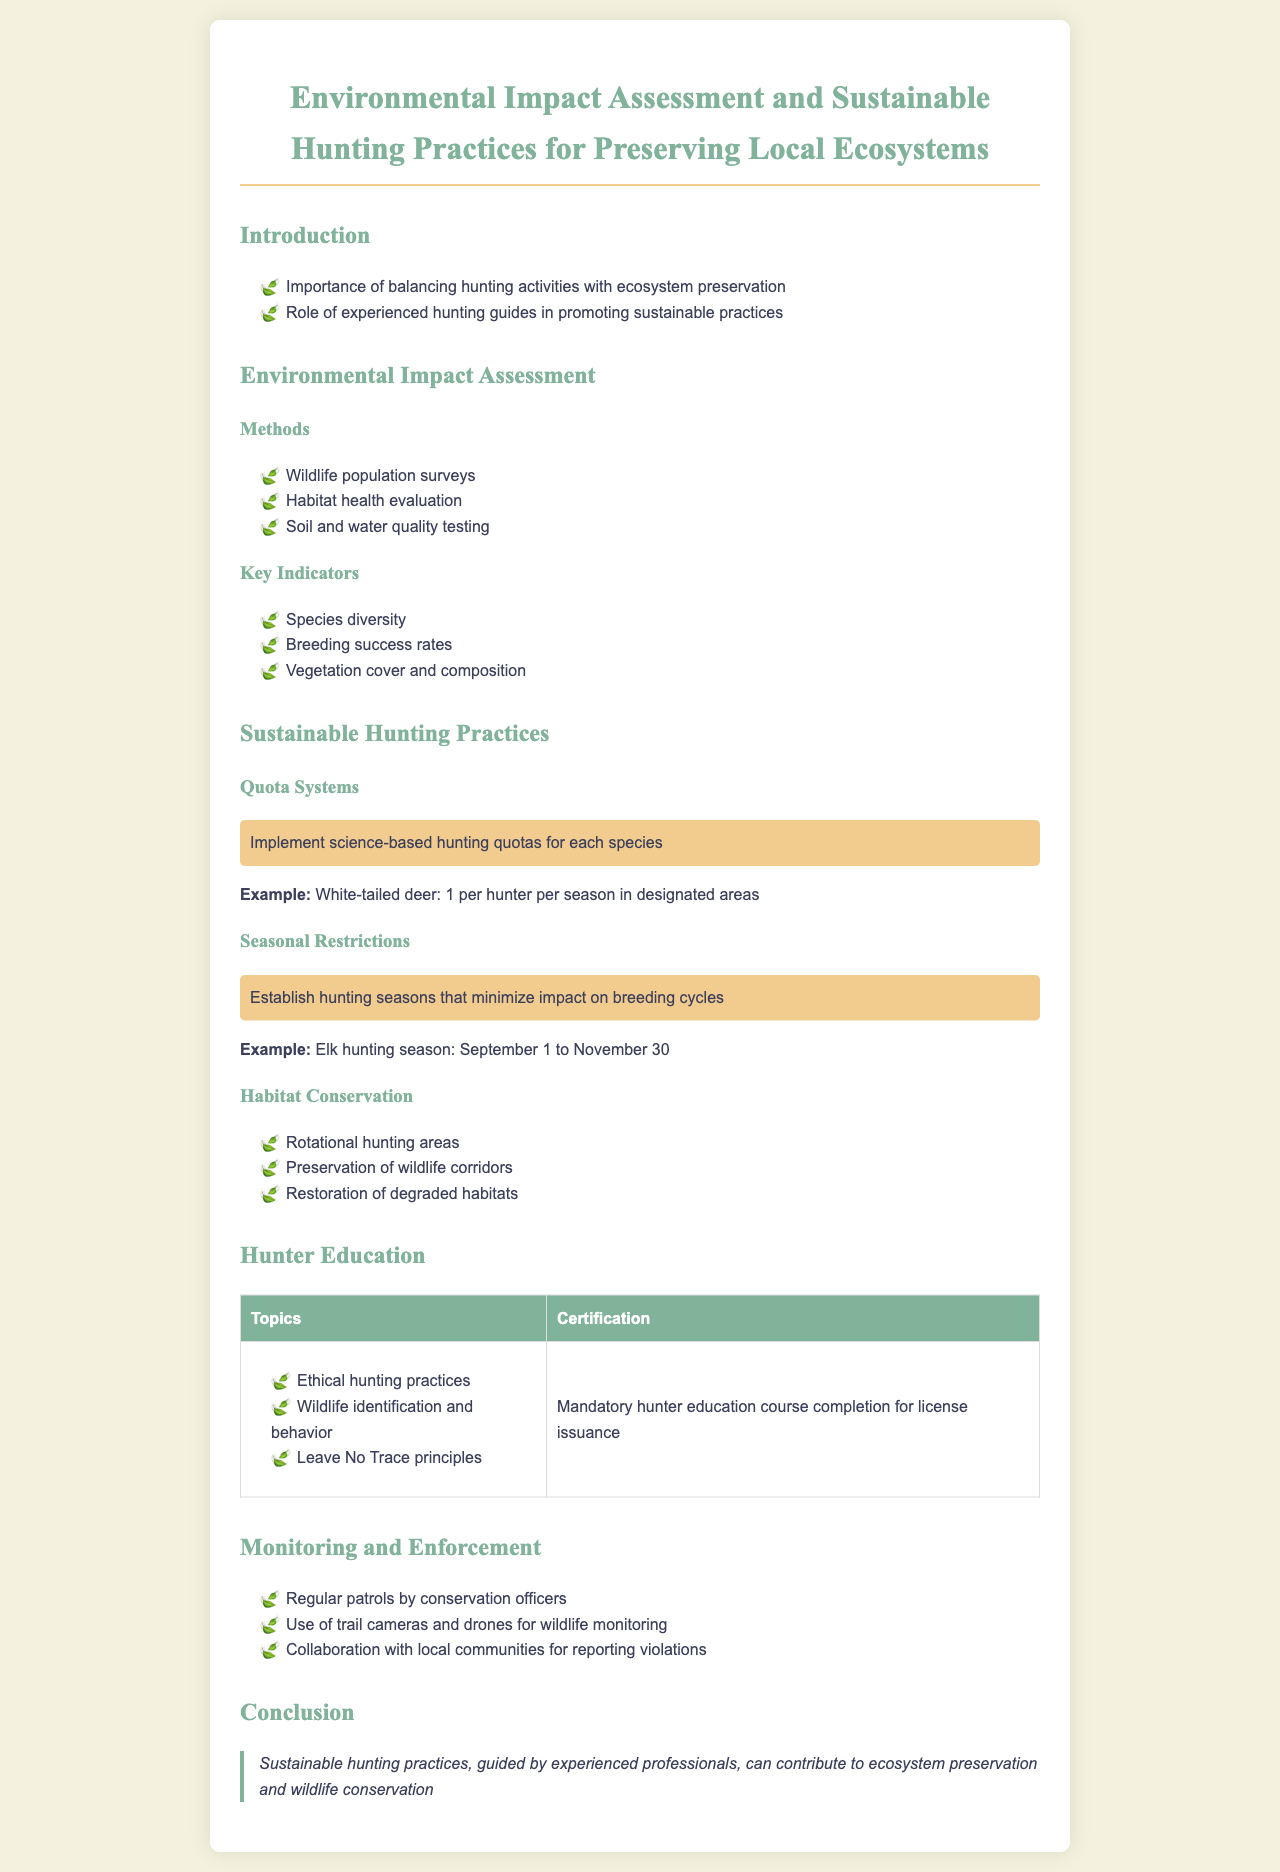What is the title of the document? The title appears at the top of the document, describing its focus on environmental assessment and hunting practices.
Answer: Environmental Impact Assessment and Sustainable Hunting Practices for Preserving Local Ecosystems What example is given for white-tailed deer hunting? The document provides a specific example regarding the hunting quota for white-tailed deer, which is provided in the quota systems section.
Answer: 1 per hunter per season in designated areas What is the duration of the elk hunting season? The document includes an example of the elk hunting season, specifying the time frame for this activity.
Answer: September 1 to November 30 Which method is mentioned for assessing habitat health? The methods used in environmental impact assessments include various evaluations, as detailed in the section on environmental impact assessment.
Answer: Habitat health evaluation What is a key indicator of ecosystem health listed in the document? The document identifies several indicators that are crucial for assessing ecosystem health within the key indicators section.
Answer: Species diversity What education topic is mandatory for hunter certification? The document outlines the necessary topics that must be covered for obtaining a hunting license, highlighting the ethical considerations in hunting.
Answer: Ethical hunting practices What is one method mentioned for monitoring wildlife? The document discusses various strategies for monitoring wildlife, including the use of certain modern technologies.
Answer: Use of trail cameras and drones How does the document suggest preserving wildlife corridors? The document outlines specific practices related to habitat conservation and the importance of wildlife corridors.
Answer: Preservation of wildlife corridors 